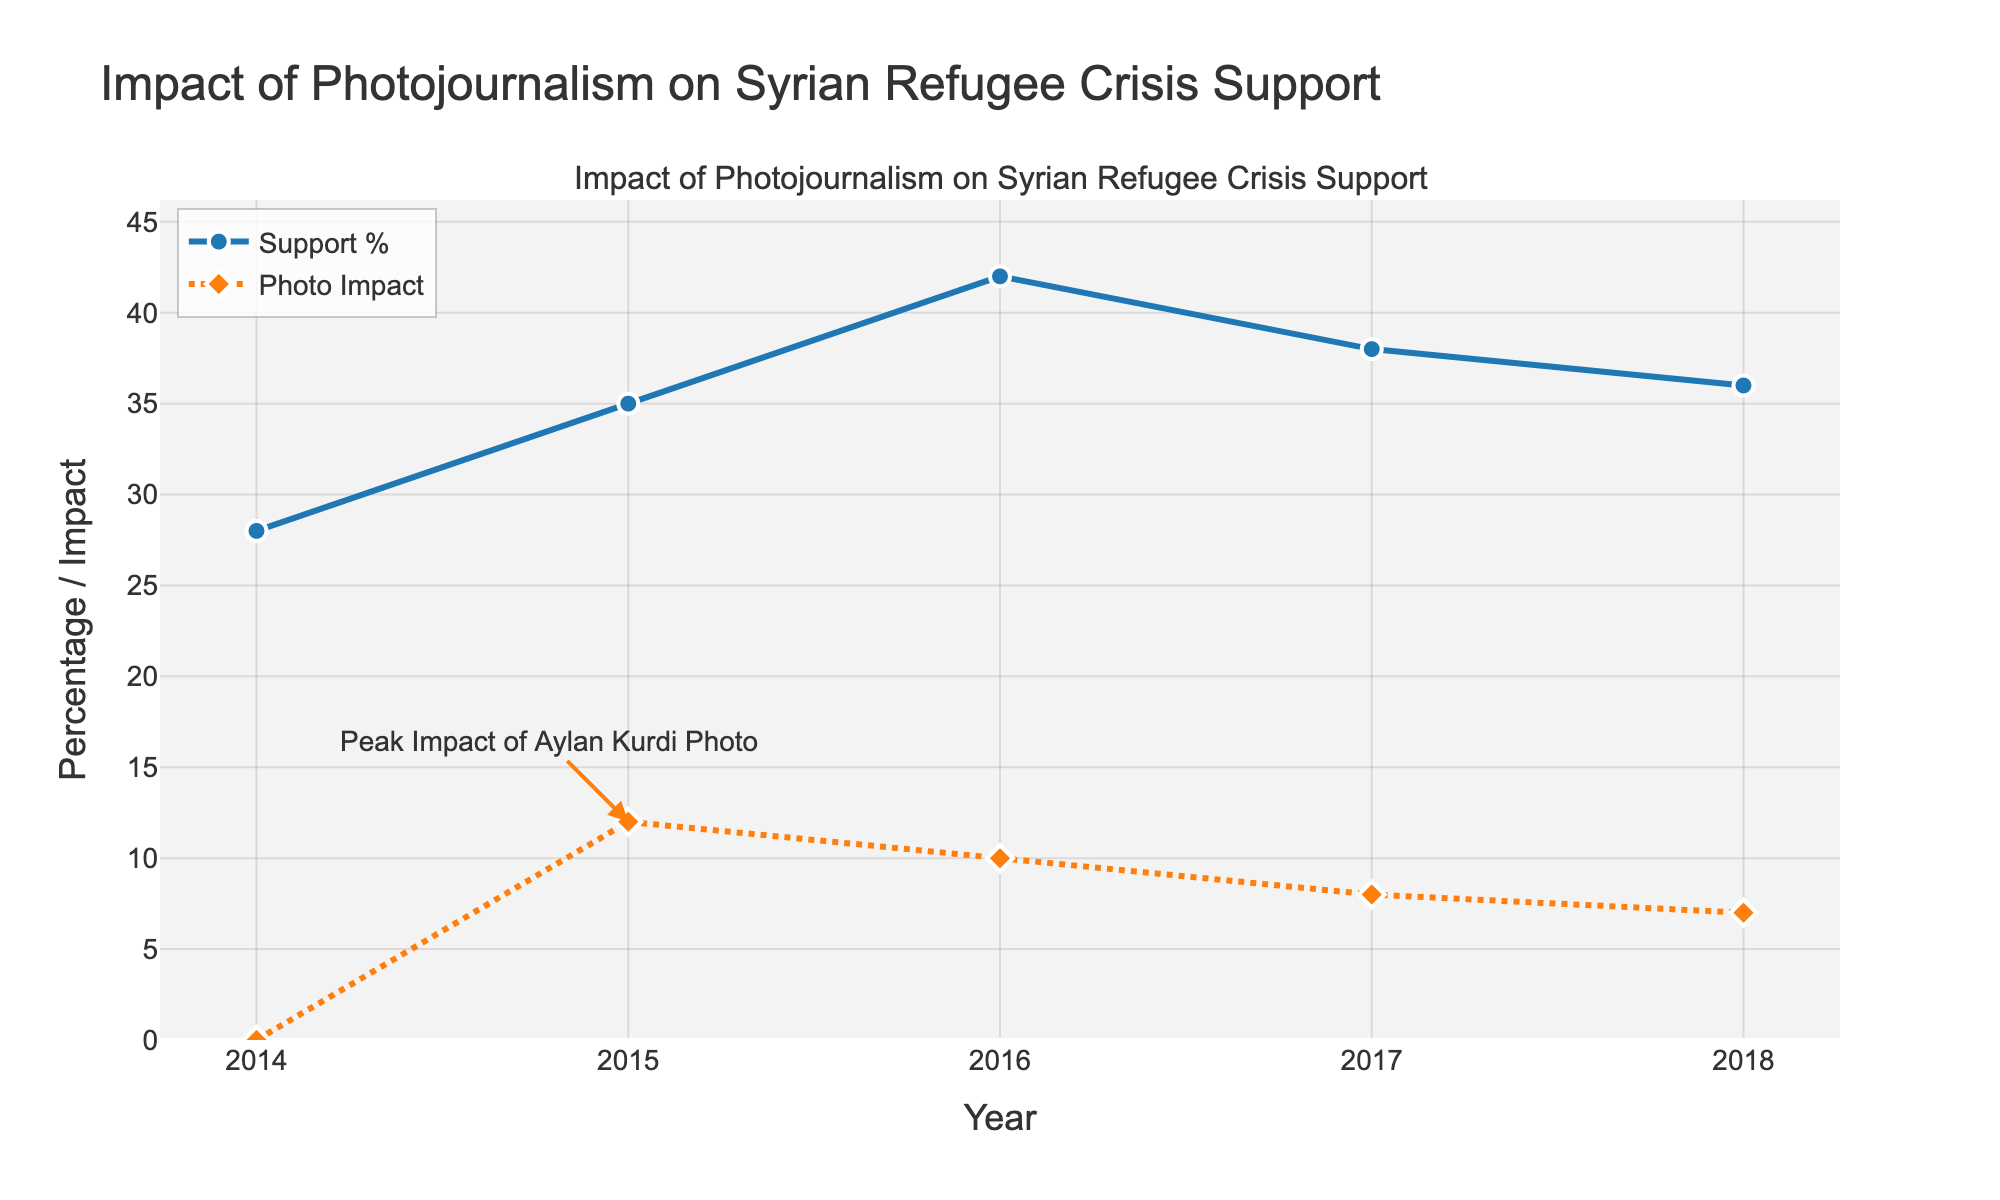What is the trend in Syrian Refugee Crisis support percentage from 2014 to 2018? The trend shows an increase from 28% in 2014 to a peak of 42% in 2016, followed by a gradual decline to 36% in 2018.
Answer: Increase, then decrease What was the impact of the Aylan Kurdi photo in 2015, and how did it change by 2018? In 2015, the impact was at its peak with a value of 12. By 2018, the impact decreased to a value of 7.
Answer: Decreased from 12 to 7 Compare the support for Syrian Refugee Crisis in 2016 to the impact of the Aylan Kurdi photo in the same year. In 2016, the support percentage for the Syrian Refugee Crisis was 42%, while the impact of the Aylan Kurdi photo was 10.
Answer: Support: 42%, Impact: 10 How much did the support for the Syrian Refugee Crisis change from 2014 to 2015? The support increased from 28% in 2014 to 35% in 2015. The change is 35 - 28 = 7%.
Answer: 7% What year shows the highest support for the Syrian Refugee Crisis, and what is the corresponding value? The year 2016 shows the highest support for the Syrian Refugee Crisis, with a value of 42%.
Answer: 2016, 42% Did the impact of the Aylan Kurdi photo reach its peak before or after the Syrian Refugee Crisis support peaked? The impact of the Aylan Kurdi photo reached its peak in 2015, which is before the Syrian Refugee Crisis support peaked in 2016.
Answer: Before What is the difference between the support for the Syrian Refugee Crisis in its highest year and its lowest year? The highest support was in 2016 at 42%, and the lowest was in 2014 at 28%. The difference is 42 - 28 = 14%.
Answer: 14% In what way does the annotation highlight the importance of the Aylan Kurdi photo in 2015? The annotation points to 2015 with the text "Peak Impact of Aylan Kurdi Photo," emphasizing its highest value and significant impact during that year.
Answer: Highlights the peak impact in 2015 Examine the trend of the Aylan Kurdi photo impact from 2015 to 2018. What pattern do you notice? The impact starts high at 12 in 2015 and then gradually decreases over the years: 10 in 2016, 8 in 2017, and 7 in 2018.
Answer: Decreasing trend Which year shows a closer value between Syrian Refugee Crisis support and Aylan Kurdi photo impact? In 2018, the Syrian Refugee Crisis support is 36%, and the Aylan Kurdi photo impact is 7, showing the smallest gap compared to other years.
Answer: 2018 